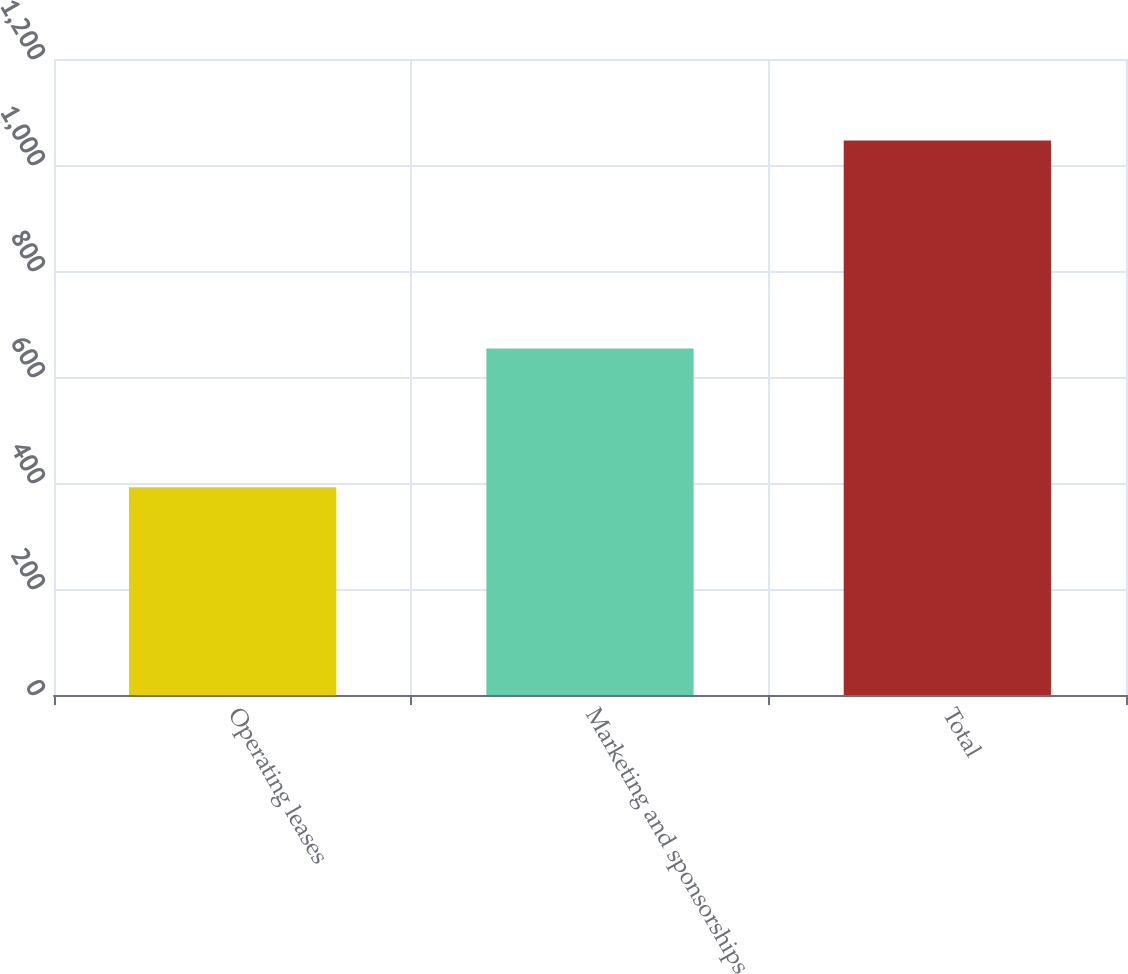Convert chart to OTSL. <chart><loc_0><loc_0><loc_500><loc_500><bar_chart><fcel>Operating leases<fcel>Marketing and sponsorships<fcel>Total<nl><fcel>392<fcel>654<fcel>1046<nl></chart> 